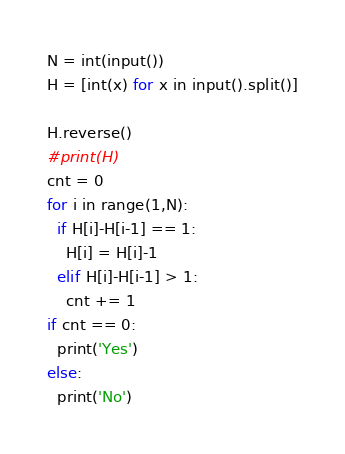<code> <loc_0><loc_0><loc_500><loc_500><_Python_>N = int(input())
H = [int(x) for x in input().split()]

H.reverse()
#print(H)
cnt = 0
for i in range(1,N):
  if H[i]-H[i-1] == 1:
    H[i] = H[i]-1
  elif H[i]-H[i-1] > 1:
    cnt += 1
if cnt == 0:
  print('Yes')
else:
  print('No')
</code> 